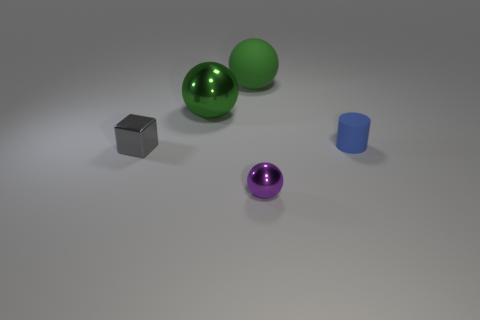What material is the other large ball that is the same color as the big metallic ball?
Your answer should be compact. Rubber. What is the material of the purple sphere?
Provide a short and direct response. Metal. Does the object on the right side of the tiny purple metal sphere have the same material as the gray thing?
Give a very brief answer. No. The matte object that is left of the purple object has what shape?
Make the answer very short. Sphere. There is a cube that is the same size as the blue cylinder; what is it made of?
Ensure brevity in your answer.  Metal. What number of objects are shiny things that are to the right of the small metallic cube or tiny things that are left of the purple sphere?
Your answer should be very brief. 3. There is a green sphere that is made of the same material as the small blue cylinder; what size is it?
Give a very brief answer. Large. What number of matte objects are either tiny yellow balls or purple objects?
Make the answer very short. 0. How big is the blue thing?
Your response must be concise. Small. Do the purple shiny ball and the gray metal object have the same size?
Give a very brief answer. Yes. 